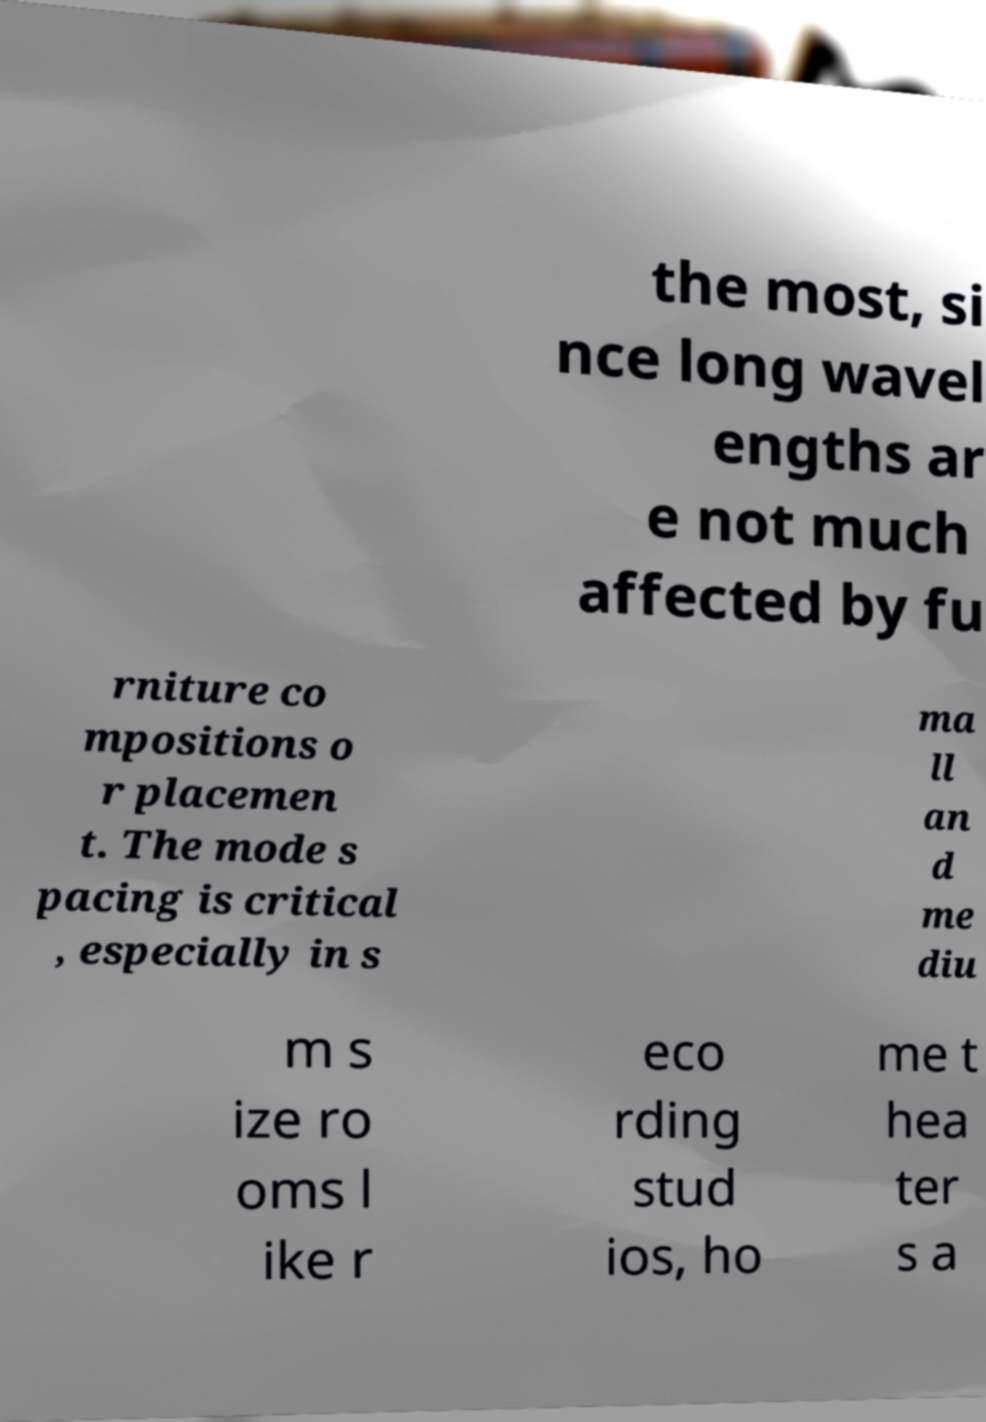There's text embedded in this image that I need extracted. Can you transcribe it verbatim? the most, si nce long wavel engths ar e not much affected by fu rniture co mpositions o r placemen t. The mode s pacing is critical , especially in s ma ll an d me diu m s ize ro oms l ike r eco rding stud ios, ho me t hea ter s a 